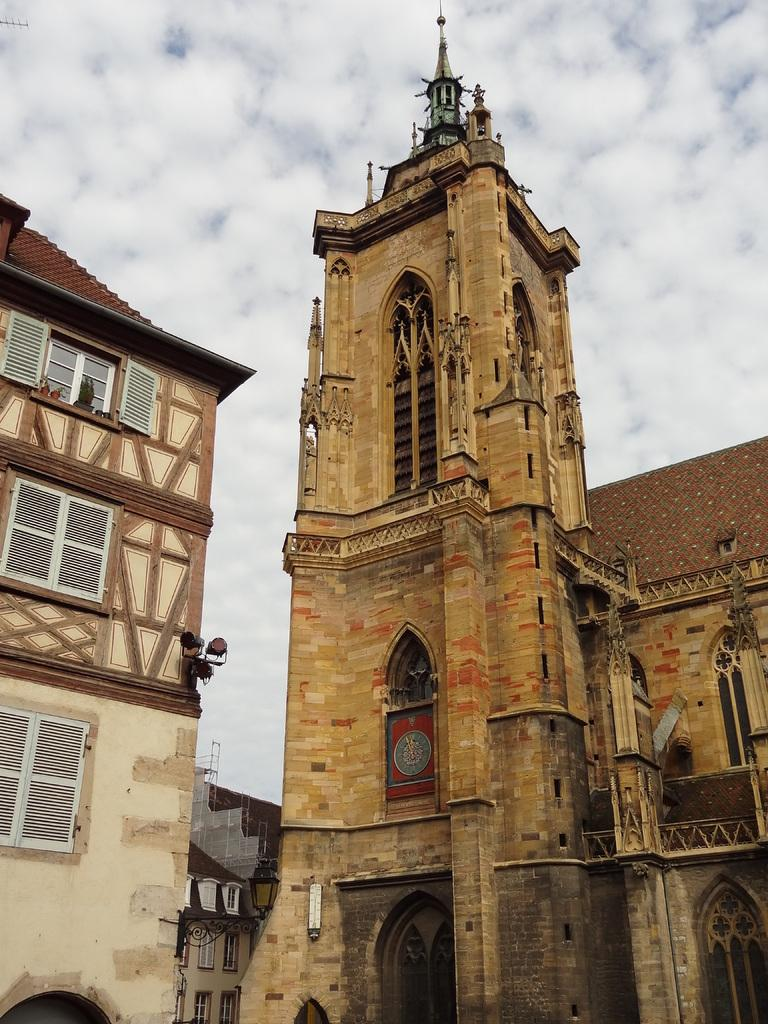What type of building is the main subject in the image? There is a church building in the image. What other building can be seen in the image? There is another building with windows opposite to the church. What is visible in the background of the image? The sky is visible in the background of the image. What can be observed in the sky? Clouds are present in the sky. What type of bath can be seen in the image? There is no bath present in the image. What system is responsible for the way the clouds are arranged in the image? The arrangement of clouds in the image is a natural occurrence and not the result of any specific system. 